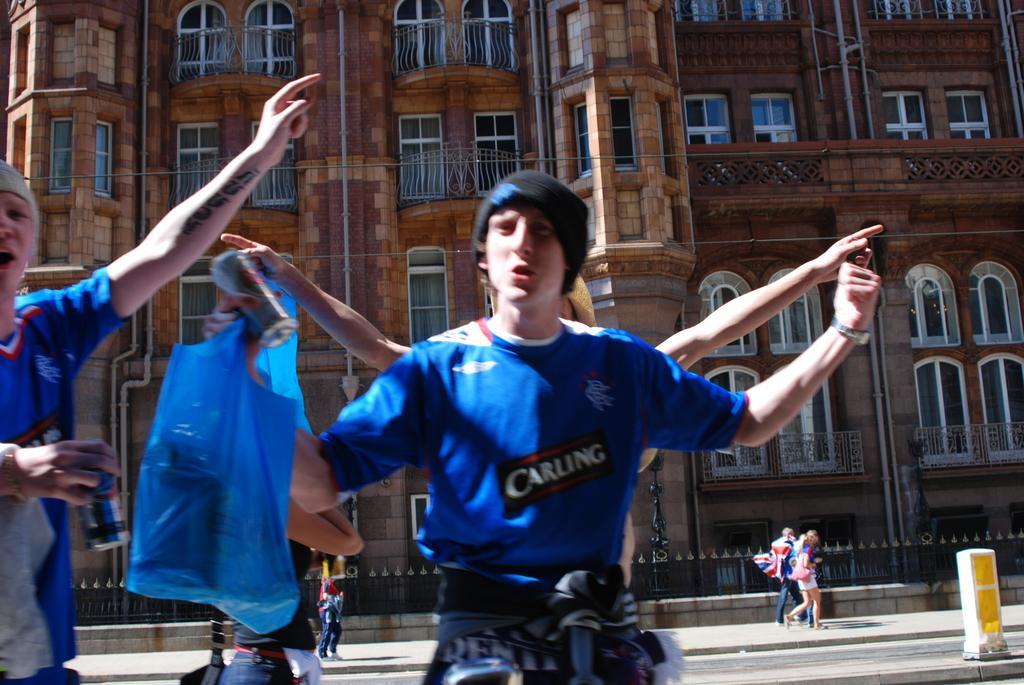Can you describe this image briefly? In the image we can see there are people wearing clothes, standing and some of them are walking, they are wearing clothes and some of them are wearing a cap. This is a plastic cover, can, road, fence, building and windows of the building. 